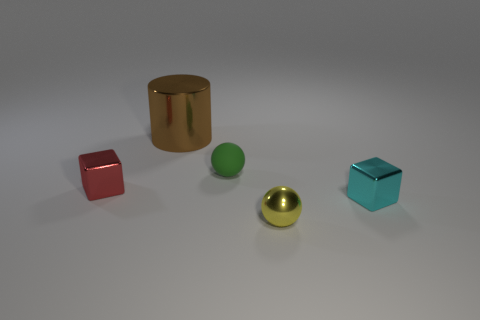What number of things are tiny metallic objects behind the metal ball or objects behind the small rubber ball?
Provide a succinct answer. 3. There is a shiny object that is to the right of the tiny green matte object and left of the cyan metal thing; what color is it?
Your answer should be very brief. Yellow. Is the number of large gray matte cylinders greater than the number of tiny cyan metallic cubes?
Your response must be concise. No. There is a small metal object behind the small cyan thing; does it have the same shape as the tiny cyan object?
Give a very brief answer. Yes. What number of rubber objects are purple cylinders or tiny yellow objects?
Give a very brief answer. 0. Are there any small red objects that have the same material as the cylinder?
Your response must be concise. Yes. What is the material of the red block?
Provide a short and direct response. Metal. There is a tiny cyan thing that is on the right side of the cube on the left side of the small metallic cube that is to the right of the rubber object; what shape is it?
Your answer should be very brief. Cube. Is the number of large brown metallic objects in front of the tiny cyan metallic thing greater than the number of large gray shiny cylinders?
Provide a succinct answer. No. There is a tiny green thing; is its shape the same as the tiny object that is to the left of the matte thing?
Your answer should be very brief. No. 